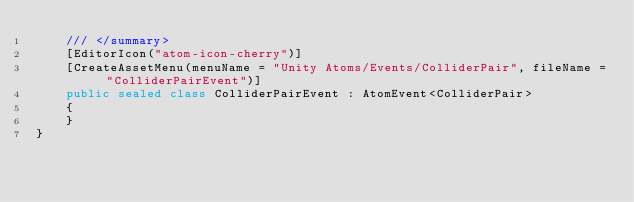<code> <loc_0><loc_0><loc_500><loc_500><_C#_>    /// </summary>
    [EditorIcon("atom-icon-cherry")]
    [CreateAssetMenu(menuName = "Unity Atoms/Events/ColliderPair", fileName = "ColliderPairEvent")]
    public sealed class ColliderPairEvent : AtomEvent<ColliderPair>
    {
    }
}
</code> 